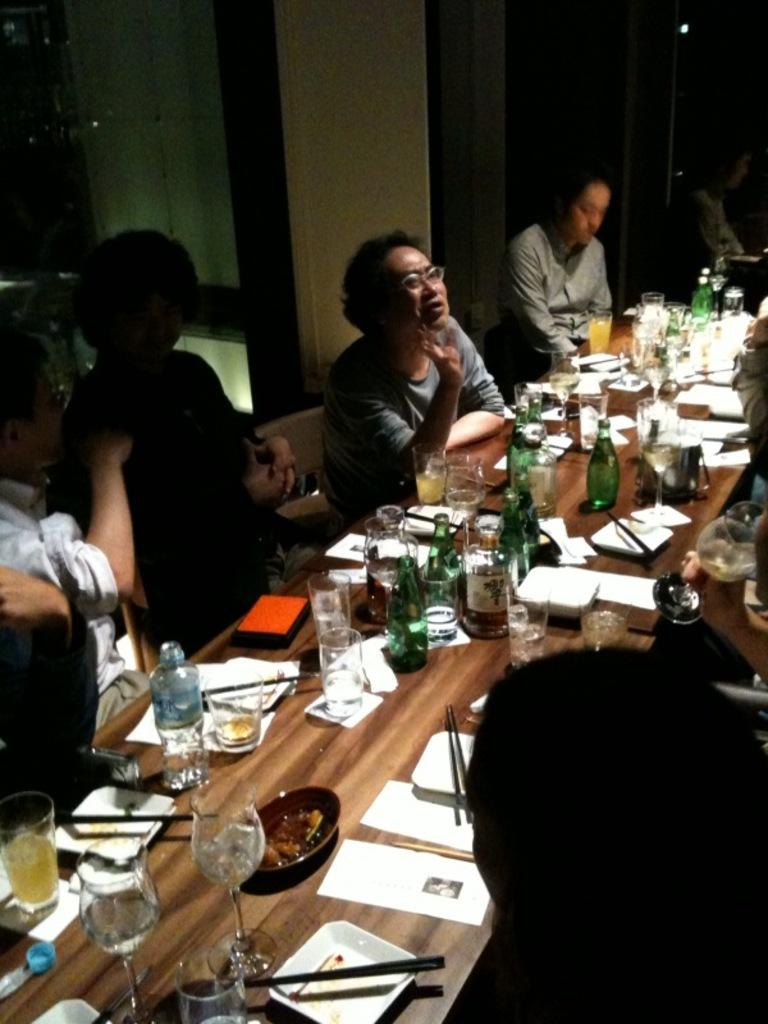How many people are in the image? There is a group of people in the image. What is present on the table in the image? There is a glass, a plate, and a bottle on the table in the image. What might the people be using the table for? The table might be used for holding the glass, plate, and bottle, which could be used for eating or drinking. What type of expansion can be seen in the image? There is no expansion present in the image. --- Facts: 1. There is a car in the image. 2. The car is red. 3. The car has four wheels. 4. The car is parked on the street. 5. There are people walking on the street. Absurd Topics: elephant, parrot, ocean Conversation: What is the main subject in the image? There is a car in the image. What color is the car? The car is red. How many wheels does the car have? The car has four wheels. Where is the car located in the image? The car is parked on the street. What else can be seen in the image? There are people walking on the street. Reasoning: Let's think step by step in order to produce the conversation. We start by identifying the main subject of the image, which is the car. Next, we describe specific features of the car, such as its color and the number of wheels it has. Then, we observe the car's location in the image, which is parked on the street. Finally, we describe any additional elements present in the image, which in this case are the people walking on the street. Absurd Question/Answer: Can you see any elephants, parrots, or ocean in the image? No, there are no elephants, parrots, or ocean present in the image. 